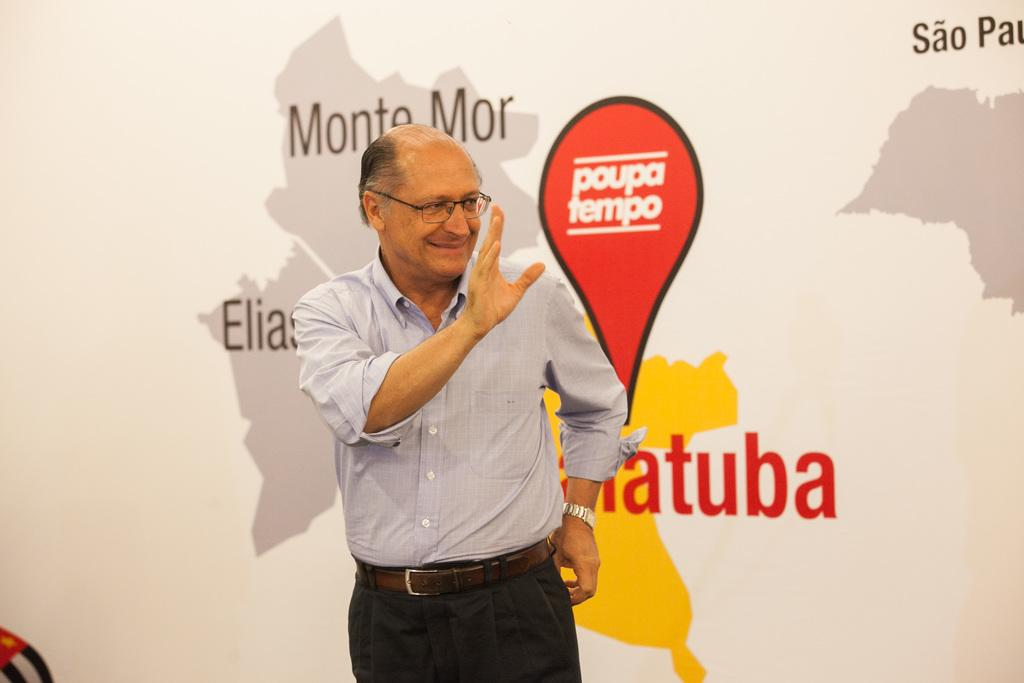What is the main subject of the image? There is a person standing in the image. What is the person doing with their hand? The person has raised one of their hands. What other object can be seen in the image? There is a map in the image. Is there any text or writing on the map? Yes, there is something written on the map. What type of monkey can be seen on the roof in the image? There is no monkey or roof present in the image; it features a person standing with a raised hand and a map with writing on it. 